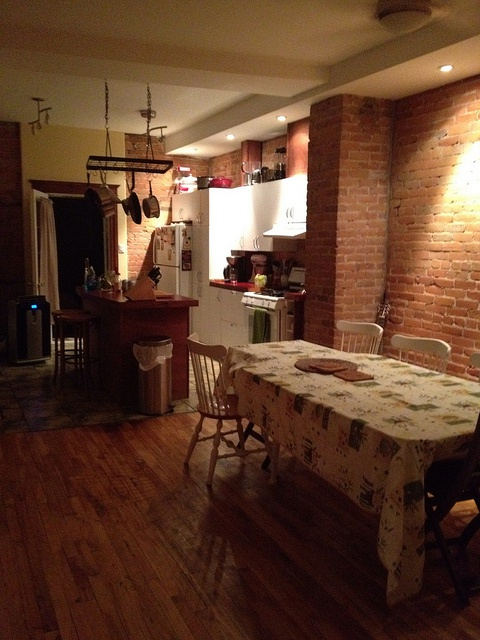Describe the objects in this image and their specific colors. I can see dining table in maroon, gray, tan, and brown tones, chair in maroon, gray, and brown tones, chair in maroon, black, and brown tones, oven in maroon, black, and gray tones, and refrigerator in maroon, gray, brown, and tan tones in this image. 